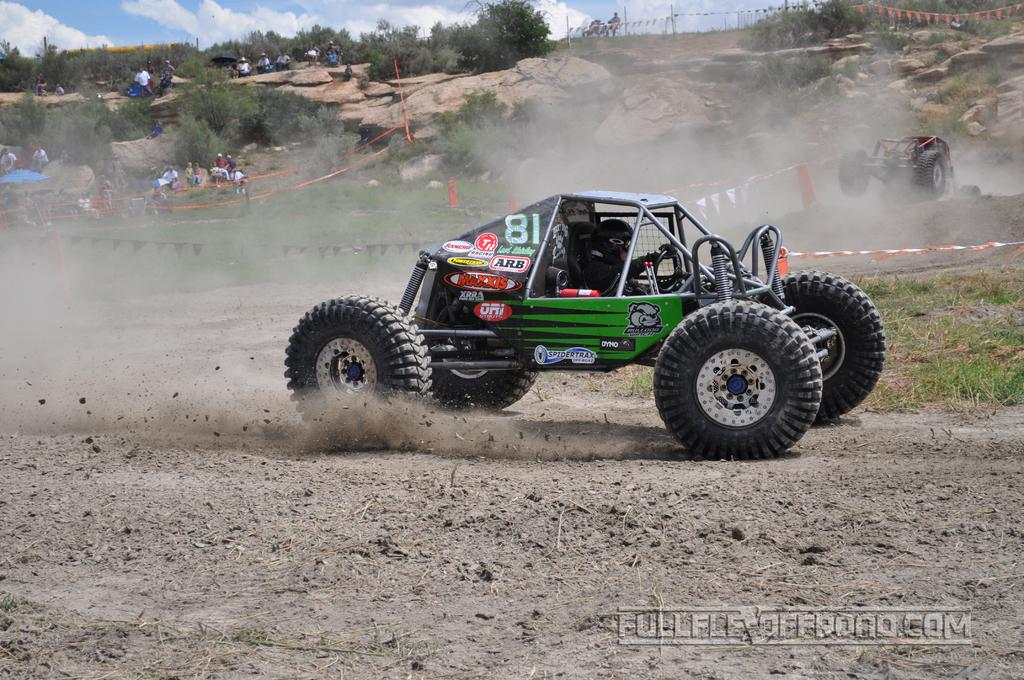What types of objects are on the ground in the image? There are vehicles on the ground in the image. Can you describe the people in the image? There are people in the image. What decorative elements can be seen in the image? Decorative flags are present in the image. What type of natural environment is visible in the image? There is grass, trees, and rocks visible in the image. What is the background of the image? The sky is visible in the background of the image, with clouds present. What type of business is being conducted in the image? There is no indication of any business being conducted in the image. How much was the payment for the foot in the image? There is no foot or payment present in the image. 